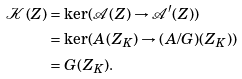Convert formula to latex. <formula><loc_0><loc_0><loc_500><loc_500>\mathcal { K } ( Z ) & = \ker ( \mathcal { A } ( Z ) \rightarrow \mathcal { A } ^ { \prime } ( Z ) ) \\ & = \ker ( A ( Z _ { K } ) \rightarrow ( A / G ) ( Z _ { K } ) ) \\ & = G ( Z _ { K } ) .</formula> 